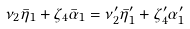Convert formula to latex. <formula><loc_0><loc_0><loc_500><loc_500>\nu _ { 2 } \bar { \eta } _ { 1 } + \zeta _ { 4 } \bar { \alpha } _ { 1 } = \nu _ { 2 } ^ { \prime } \bar { \eta } _ { 1 } ^ { \prime } + \zeta _ { 4 } ^ { \prime } \alpha _ { 1 } ^ { \prime }</formula> 